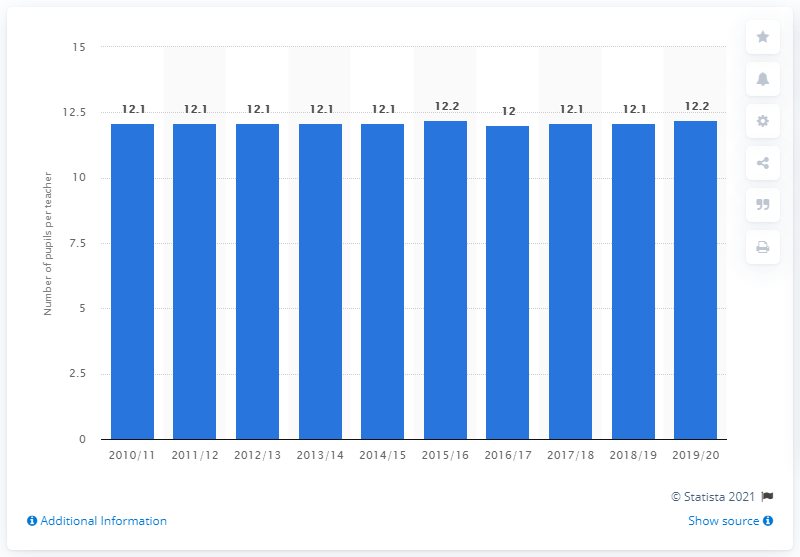Outline some significant characteristics in this image. In the 2019/20 school year, the pupil-to-teacher ratio in Sweden was 12.2... 